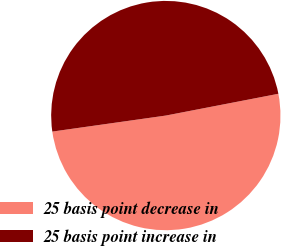<chart> <loc_0><loc_0><loc_500><loc_500><pie_chart><fcel>25 basis point decrease in<fcel>25 basis point increase in<nl><fcel>50.81%<fcel>49.19%<nl></chart> 